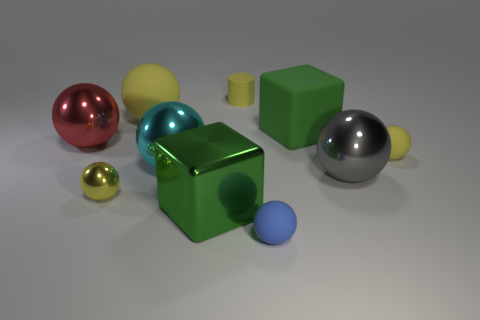Subtract all cyan cubes. How many yellow spheres are left? 3 Subtract 4 spheres. How many spheres are left? 3 Subtract all small yellow matte spheres. How many spheres are left? 6 Subtract all blue balls. How many balls are left? 6 Subtract all gray spheres. Subtract all blue cubes. How many spheres are left? 6 Subtract all blocks. How many objects are left? 8 Subtract 1 green cubes. How many objects are left? 9 Subtract all tiny metallic spheres. Subtract all cyan shiny objects. How many objects are left? 8 Add 6 red metal objects. How many red metal objects are left? 7 Add 2 metallic cubes. How many metallic cubes exist? 3 